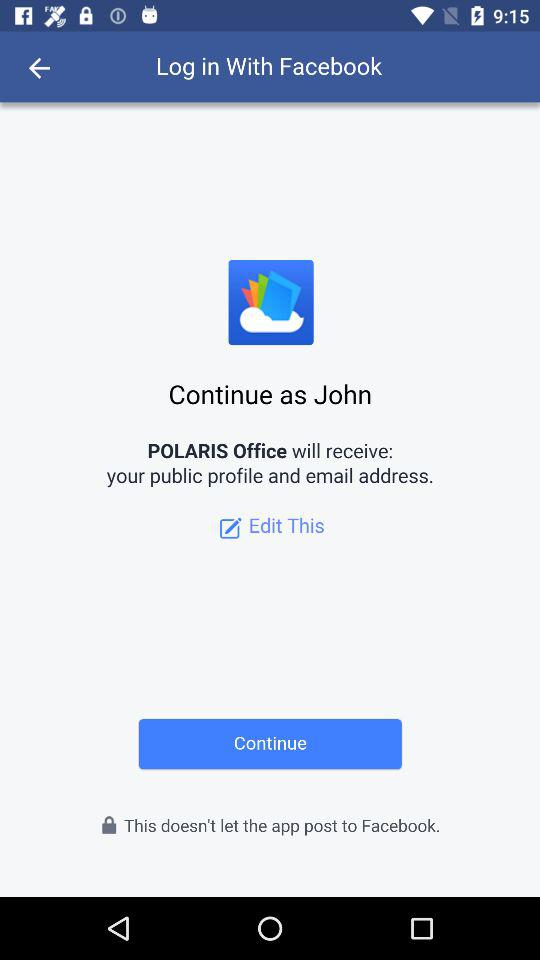What application is asking for permission? The application asking for permission is "POLARIS Office". 